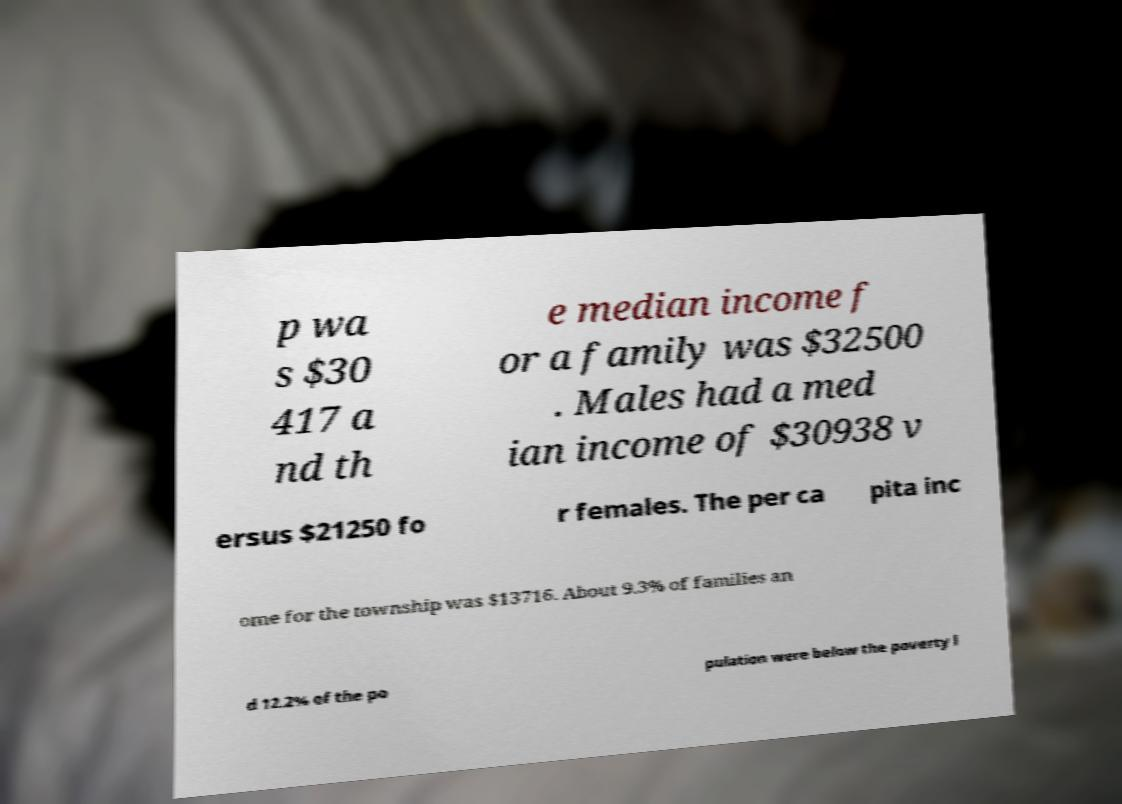For documentation purposes, I need the text within this image transcribed. Could you provide that? p wa s $30 417 a nd th e median income f or a family was $32500 . Males had a med ian income of $30938 v ersus $21250 fo r females. The per ca pita inc ome for the township was $13716. About 9.3% of families an d 12.2% of the po pulation were below the poverty l 